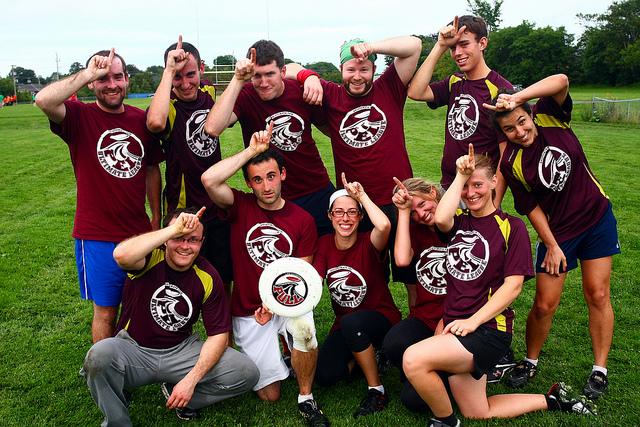Do they have matching shirts?
Be succinct. Yes. Are they all smiling?
Be succinct. No. What sport does this team play together?
Concise answer only. Frisbee. 